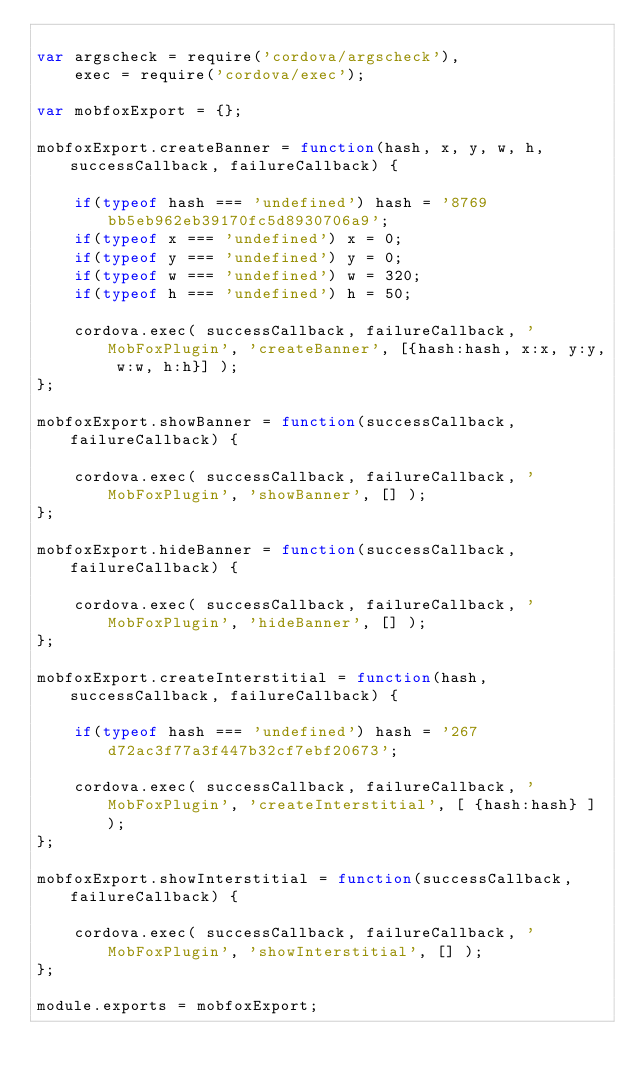Convert code to text. <code><loc_0><loc_0><loc_500><loc_500><_JavaScript_>
var argscheck = require('cordova/argscheck'),
    exec = require('cordova/exec');

var mobfoxExport = {};

mobfoxExport.createBanner = function(hash, x, y, w, h, successCallback, failureCallback) {
	
	if(typeof hash === 'undefined') hash = '8769bb5eb962eb39170fc5d8930706a9';
	if(typeof x === 'undefined') x = 0;
	if(typeof y === 'undefined') y = 0;
	if(typeof w === 'undefined') w = 320;
	if(typeof h === 'undefined') h = 50;
	
	cordova.exec( successCallback, failureCallback, 'MobFoxPlugin', 'createBanner', [{hash:hash, x:x, y:y, w:w, h:h}] );
};

mobfoxExport.showBanner = function(successCallback, failureCallback) {

	cordova.exec( successCallback, failureCallback, 'MobFoxPlugin', 'showBanner', [] );
};

mobfoxExport.hideBanner = function(successCallback, failureCallback) {

	cordova.exec( successCallback, failureCallback, 'MobFoxPlugin', 'hideBanner', [] );
};

mobfoxExport.createInterstitial = function(hash, successCallback, failureCallback) {

	if(typeof hash === 'undefined') hash = '267d72ac3f77a3f447b32cf7ebf20673';

	cordova.exec( successCallback, failureCallback, 'MobFoxPlugin', 'createInterstitial', [ {hash:hash} ] );
};

mobfoxExport.showInterstitial = function(successCallback, failureCallback) {

	cordova.exec( successCallback, failureCallback, 'MobFoxPlugin', 'showInterstitial', [] );
};

module.exports = mobfoxExport;

</code> 